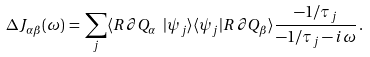<formula> <loc_0><loc_0><loc_500><loc_500>\Delta J _ { \alpha \beta } ( \omega ) \, = \, \sum _ { j } \langle R \, \partial Q _ { \alpha } \ | \psi _ { j } \rangle \langle \psi _ { j } | R \, \partial Q _ { \beta } \rangle \frac { - 1 / \tau _ { j } } { - 1 / \tau _ { j } - i \omega } \, .</formula> 